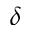Convert formula to latex. <formula><loc_0><loc_0><loc_500><loc_500>\delta</formula> 